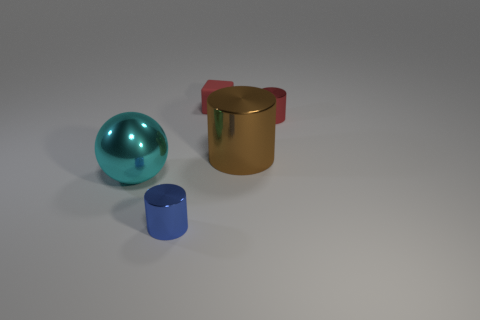There is a red matte cube; does it have the same size as the shiny cylinder that is in front of the cyan object?
Your response must be concise. Yes. What is the color of the object that is both behind the large brown metal cylinder and in front of the red block?
Offer a terse response. Red. What number of other objects are the same shape as the rubber object?
Offer a terse response. 0. There is a object in front of the large ball; does it have the same color as the small metal object to the right of the small blue cylinder?
Your answer should be very brief. No. Do the cube that is on the right side of the big ball and the red thing that is on the right side of the rubber cube have the same size?
Your answer should be compact. Yes. Are there any other things that are made of the same material as the brown thing?
Offer a terse response. Yes. What material is the tiny red thing that is on the left side of the big metal thing that is right of the metal thing that is in front of the cyan sphere?
Keep it short and to the point. Rubber. Is the shape of the brown metallic object the same as the small red matte thing?
Your answer should be compact. No. What is the material of the big brown thing that is the same shape as the blue shiny thing?
Your answer should be compact. Metal. How many spheres have the same color as the small block?
Provide a succinct answer. 0. 